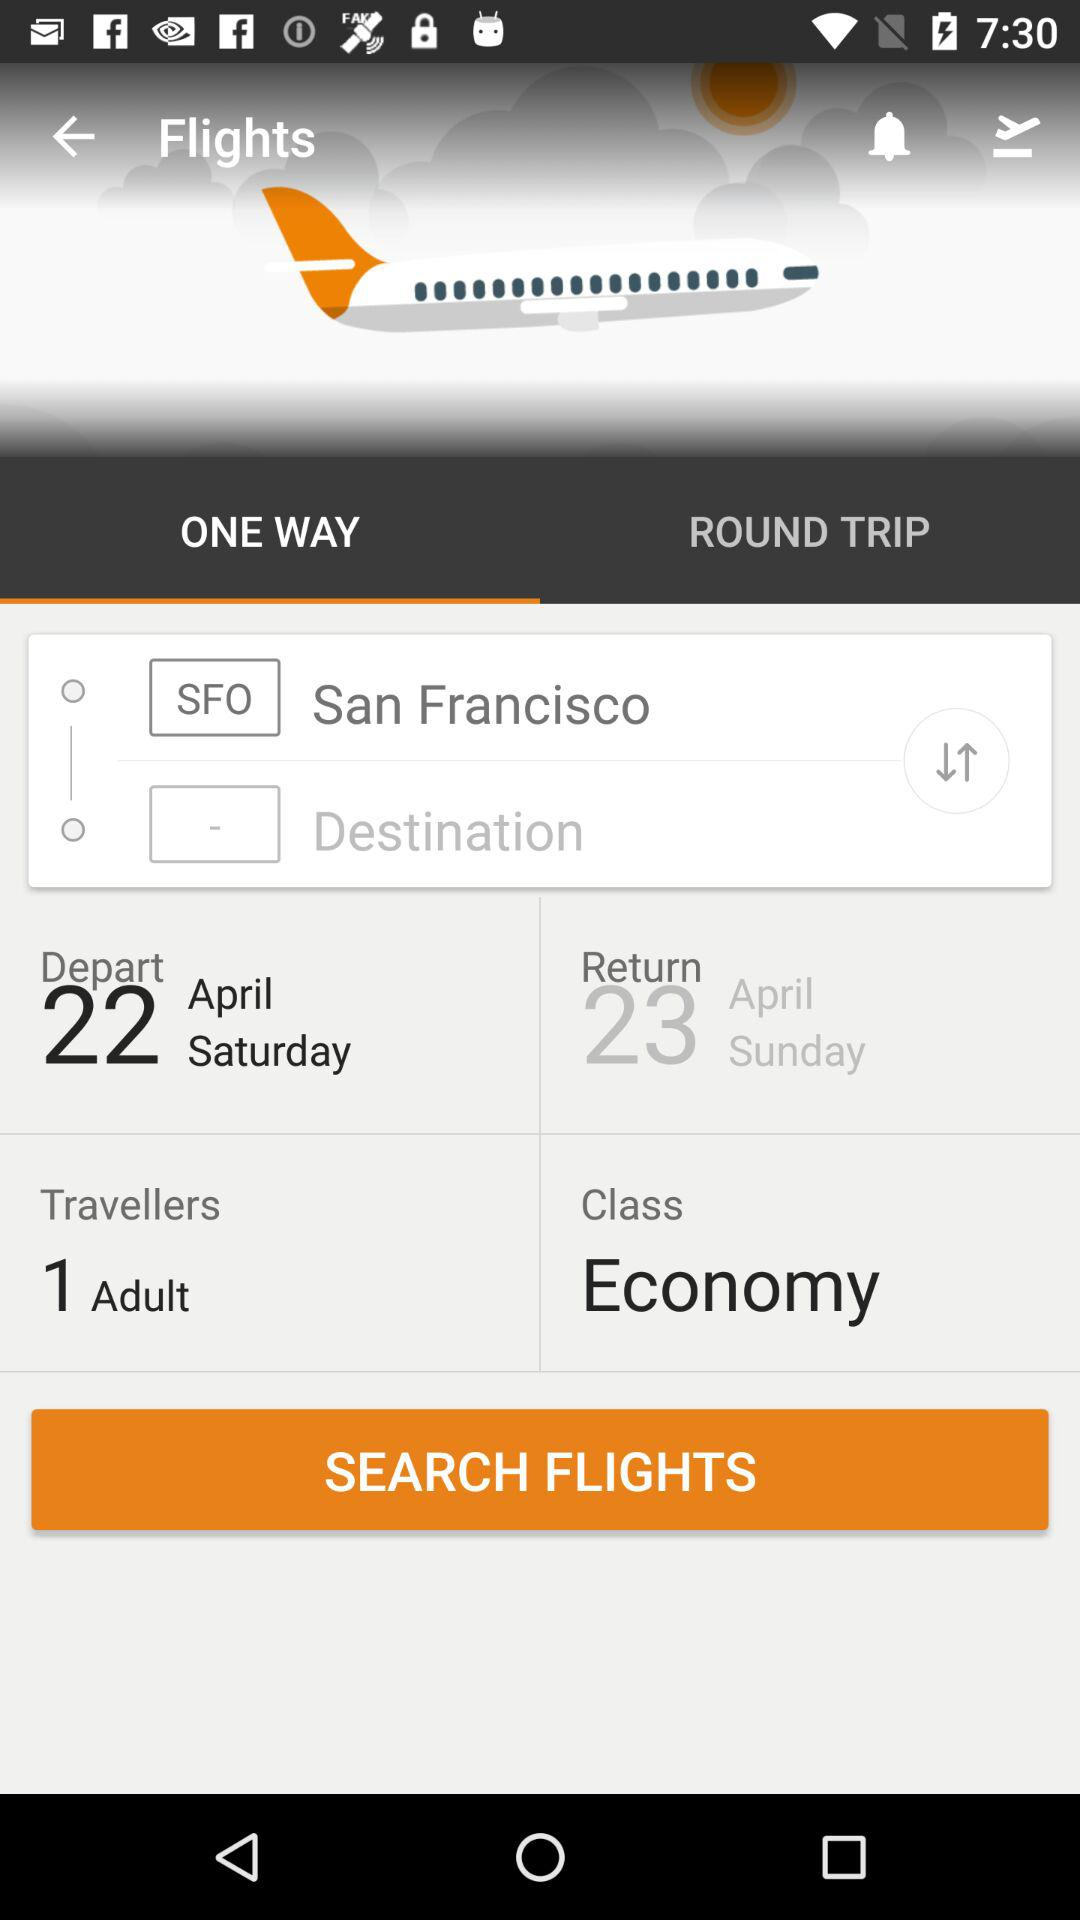From what place does the flight take off? The flight takes off from San Francisco. 